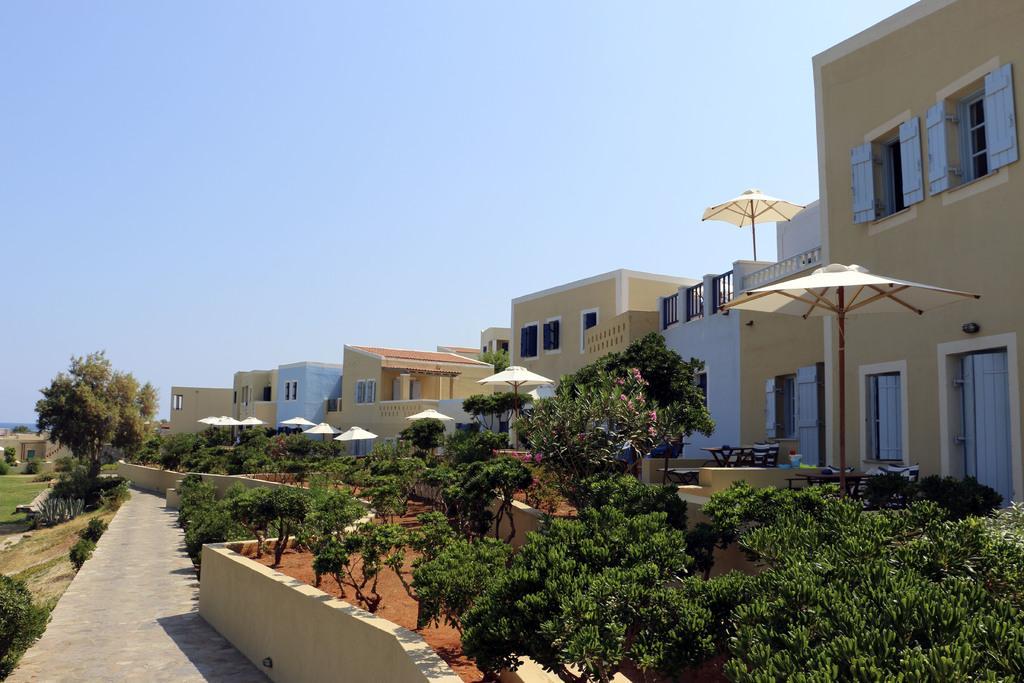How would you summarize this image in a sentence or two? This image is taken outdoors. At the top of the image there is a sky. At the bottom of the image there is a road and there is a ground with grass on it. In the middle of the image there are many trees and plants on the ground and there are a few umbrellas and tables on the ground. In the background there are a few houses with walls, windows, doors, roofs and railings. 